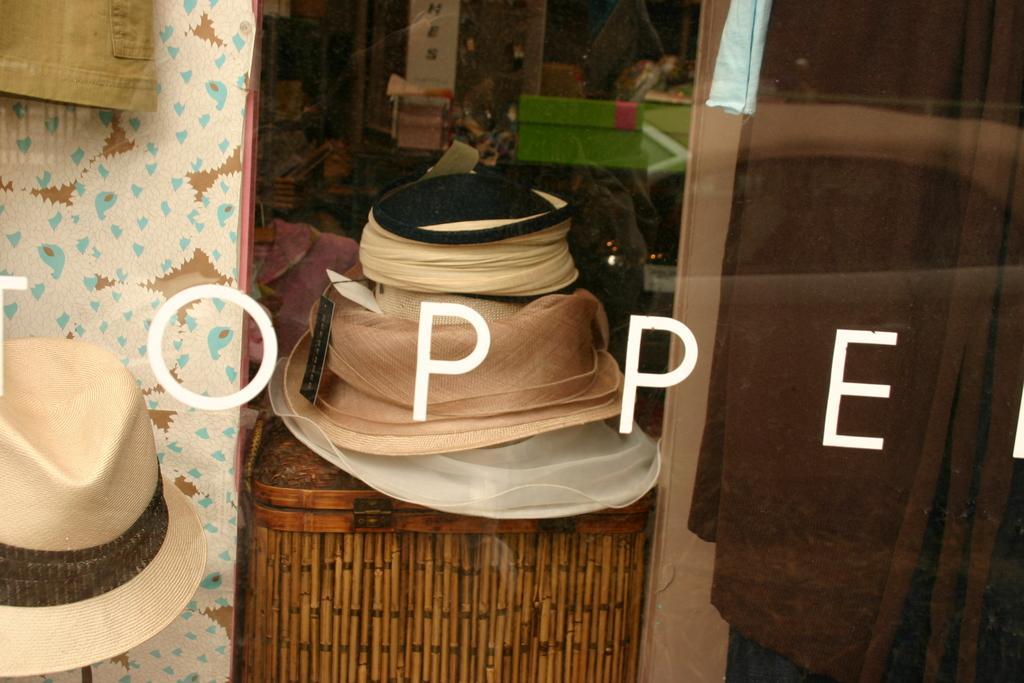Describe this image in one or two sentences. In this image we can see hats, wooden box and a few more objects. Here we can see some edited text. 